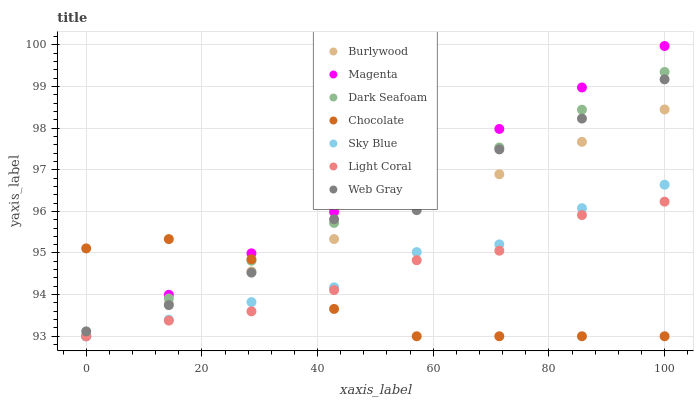Does Chocolate have the minimum area under the curve?
Answer yes or no. Yes. Does Magenta have the maximum area under the curve?
Answer yes or no. Yes. Does Burlywood have the minimum area under the curve?
Answer yes or no. No. Does Burlywood have the maximum area under the curve?
Answer yes or no. No. Is Magenta the smoothest?
Answer yes or no. Yes. Is Web Gray the roughest?
Answer yes or no. Yes. Is Burlywood the smoothest?
Answer yes or no. No. Is Burlywood the roughest?
Answer yes or no. No. Does Burlywood have the lowest value?
Answer yes or no. Yes. Does Magenta have the highest value?
Answer yes or no. Yes. Does Burlywood have the highest value?
Answer yes or no. No. Is Light Coral less than Web Gray?
Answer yes or no. Yes. Is Web Gray greater than Sky Blue?
Answer yes or no. Yes. Does Magenta intersect Web Gray?
Answer yes or no. Yes. Is Magenta less than Web Gray?
Answer yes or no. No. Is Magenta greater than Web Gray?
Answer yes or no. No. Does Light Coral intersect Web Gray?
Answer yes or no. No. 